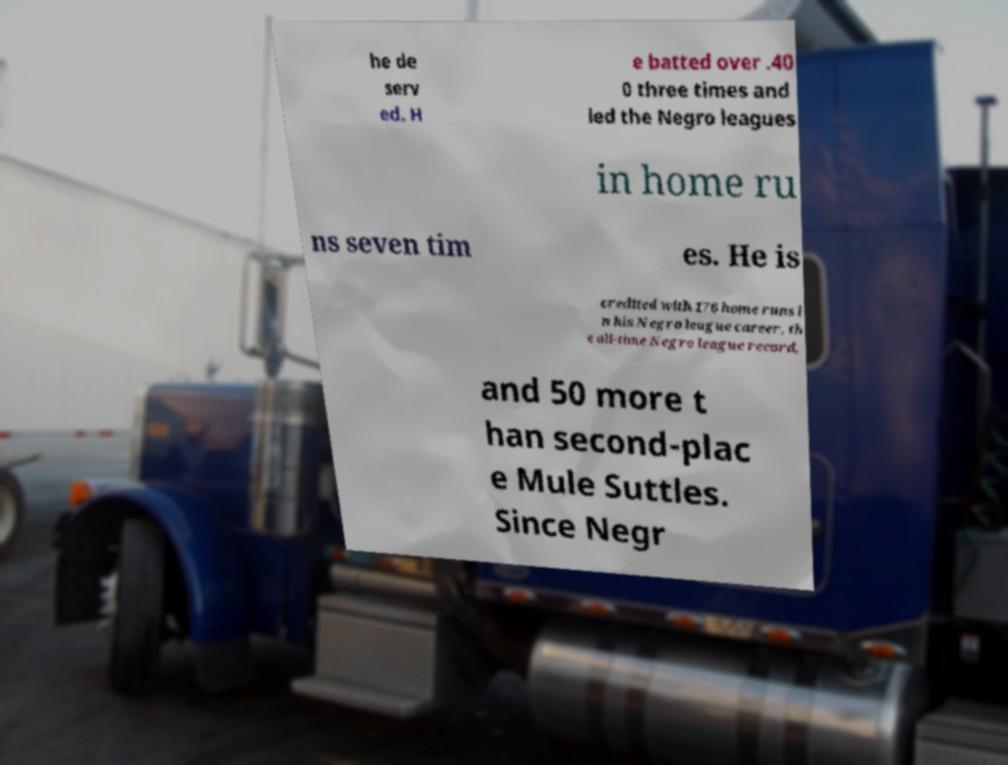There's text embedded in this image that I need extracted. Can you transcribe it verbatim? he de serv ed. H e batted over .40 0 three times and led the Negro leagues in home ru ns seven tim es. He is credited with 176 home runs i n his Negro league career, th e all-time Negro league record, and 50 more t han second-plac e Mule Suttles. Since Negr 